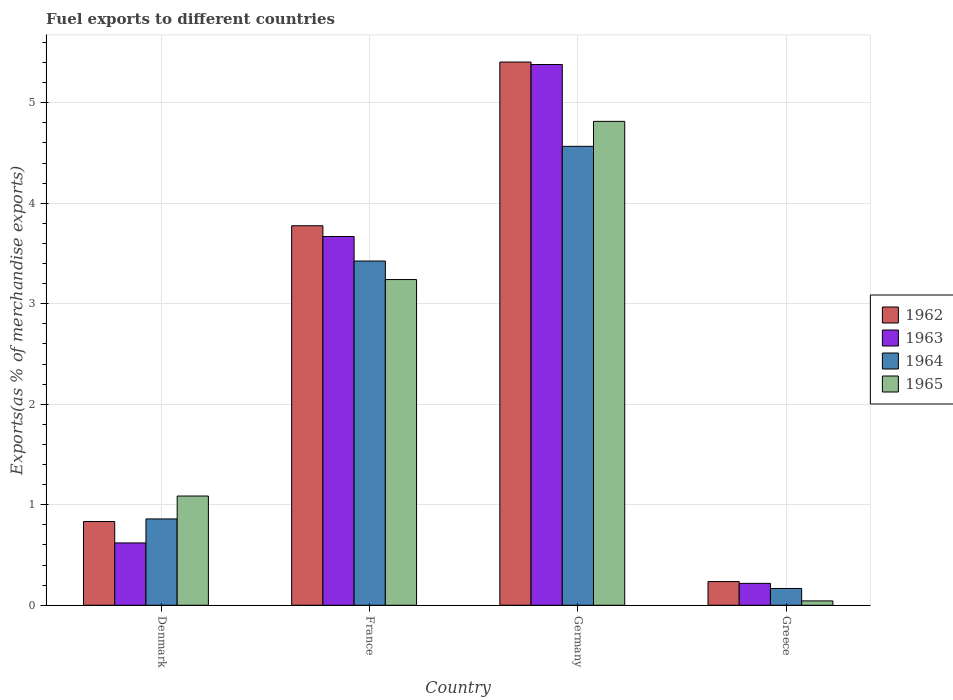How many different coloured bars are there?
Give a very brief answer. 4. How many groups of bars are there?
Ensure brevity in your answer.  4. Are the number of bars on each tick of the X-axis equal?
Make the answer very short. Yes. In how many cases, is the number of bars for a given country not equal to the number of legend labels?
Ensure brevity in your answer.  0. What is the percentage of exports to different countries in 1965 in Denmark?
Your answer should be very brief. 1.09. Across all countries, what is the maximum percentage of exports to different countries in 1963?
Offer a terse response. 5.38. Across all countries, what is the minimum percentage of exports to different countries in 1962?
Your answer should be very brief. 0.24. In which country was the percentage of exports to different countries in 1965 minimum?
Keep it short and to the point. Greece. What is the total percentage of exports to different countries in 1963 in the graph?
Provide a succinct answer. 9.89. What is the difference between the percentage of exports to different countries in 1963 in Denmark and that in Greece?
Give a very brief answer. 0.4. What is the difference between the percentage of exports to different countries in 1965 in Greece and the percentage of exports to different countries in 1962 in Denmark?
Your answer should be very brief. -0.79. What is the average percentage of exports to different countries in 1962 per country?
Provide a succinct answer. 2.56. What is the difference between the percentage of exports to different countries of/in 1962 and percentage of exports to different countries of/in 1964 in Denmark?
Keep it short and to the point. -0.03. In how many countries, is the percentage of exports to different countries in 1964 greater than 2 %?
Your response must be concise. 2. What is the ratio of the percentage of exports to different countries in 1964 in Germany to that in Greece?
Provide a short and direct response. 27.34. Is the difference between the percentage of exports to different countries in 1962 in Germany and Greece greater than the difference between the percentage of exports to different countries in 1964 in Germany and Greece?
Your answer should be very brief. Yes. What is the difference between the highest and the second highest percentage of exports to different countries in 1964?
Keep it short and to the point. -2.57. What is the difference between the highest and the lowest percentage of exports to different countries in 1964?
Offer a very short reply. 4.4. In how many countries, is the percentage of exports to different countries in 1962 greater than the average percentage of exports to different countries in 1962 taken over all countries?
Ensure brevity in your answer.  2. Is the sum of the percentage of exports to different countries in 1964 in Denmark and Germany greater than the maximum percentage of exports to different countries in 1965 across all countries?
Your response must be concise. Yes. Is it the case that in every country, the sum of the percentage of exports to different countries in 1965 and percentage of exports to different countries in 1962 is greater than the percentage of exports to different countries in 1964?
Your answer should be compact. Yes. How many countries are there in the graph?
Offer a terse response. 4. Are the values on the major ticks of Y-axis written in scientific E-notation?
Make the answer very short. No. Does the graph contain any zero values?
Ensure brevity in your answer.  No. How many legend labels are there?
Give a very brief answer. 4. What is the title of the graph?
Keep it short and to the point. Fuel exports to different countries. Does "1987" appear as one of the legend labels in the graph?
Provide a short and direct response. No. What is the label or title of the Y-axis?
Ensure brevity in your answer.  Exports(as % of merchandise exports). What is the Exports(as % of merchandise exports) of 1962 in Denmark?
Ensure brevity in your answer.  0.83. What is the Exports(as % of merchandise exports) of 1963 in Denmark?
Provide a succinct answer. 0.62. What is the Exports(as % of merchandise exports) in 1964 in Denmark?
Offer a terse response. 0.86. What is the Exports(as % of merchandise exports) of 1965 in Denmark?
Ensure brevity in your answer.  1.09. What is the Exports(as % of merchandise exports) of 1962 in France?
Make the answer very short. 3.78. What is the Exports(as % of merchandise exports) of 1963 in France?
Ensure brevity in your answer.  3.67. What is the Exports(as % of merchandise exports) in 1964 in France?
Your response must be concise. 3.43. What is the Exports(as % of merchandise exports) in 1965 in France?
Ensure brevity in your answer.  3.24. What is the Exports(as % of merchandise exports) in 1962 in Germany?
Provide a succinct answer. 5.4. What is the Exports(as % of merchandise exports) of 1963 in Germany?
Offer a terse response. 5.38. What is the Exports(as % of merchandise exports) in 1964 in Germany?
Offer a terse response. 4.57. What is the Exports(as % of merchandise exports) in 1965 in Germany?
Your answer should be compact. 4.81. What is the Exports(as % of merchandise exports) of 1962 in Greece?
Make the answer very short. 0.24. What is the Exports(as % of merchandise exports) in 1963 in Greece?
Offer a very short reply. 0.22. What is the Exports(as % of merchandise exports) of 1964 in Greece?
Your answer should be compact. 0.17. What is the Exports(as % of merchandise exports) in 1965 in Greece?
Your response must be concise. 0.04. Across all countries, what is the maximum Exports(as % of merchandise exports) of 1962?
Offer a terse response. 5.4. Across all countries, what is the maximum Exports(as % of merchandise exports) of 1963?
Your answer should be compact. 5.38. Across all countries, what is the maximum Exports(as % of merchandise exports) in 1964?
Offer a very short reply. 4.57. Across all countries, what is the maximum Exports(as % of merchandise exports) in 1965?
Your response must be concise. 4.81. Across all countries, what is the minimum Exports(as % of merchandise exports) in 1962?
Make the answer very short. 0.24. Across all countries, what is the minimum Exports(as % of merchandise exports) in 1963?
Make the answer very short. 0.22. Across all countries, what is the minimum Exports(as % of merchandise exports) of 1964?
Offer a terse response. 0.17. Across all countries, what is the minimum Exports(as % of merchandise exports) of 1965?
Offer a very short reply. 0.04. What is the total Exports(as % of merchandise exports) in 1962 in the graph?
Ensure brevity in your answer.  10.25. What is the total Exports(as % of merchandise exports) in 1963 in the graph?
Your answer should be very brief. 9.89. What is the total Exports(as % of merchandise exports) of 1964 in the graph?
Offer a very short reply. 9.02. What is the total Exports(as % of merchandise exports) of 1965 in the graph?
Provide a succinct answer. 9.19. What is the difference between the Exports(as % of merchandise exports) in 1962 in Denmark and that in France?
Offer a very short reply. -2.94. What is the difference between the Exports(as % of merchandise exports) of 1963 in Denmark and that in France?
Your response must be concise. -3.05. What is the difference between the Exports(as % of merchandise exports) in 1964 in Denmark and that in France?
Provide a succinct answer. -2.57. What is the difference between the Exports(as % of merchandise exports) in 1965 in Denmark and that in France?
Make the answer very short. -2.15. What is the difference between the Exports(as % of merchandise exports) of 1962 in Denmark and that in Germany?
Ensure brevity in your answer.  -4.57. What is the difference between the Exports(as % of merchandise exports) of 1963 in Denmark and that in Germany?
Provide a succinct answer. -4.76. What is the difference between the Exports(as % of merchandise exports) of 1964 in Denmark and that in Germany?
Your answer should be very brief. -3.71. What is the difference between the Exports(as % of merchandise exports) of 1965 in Denmark and that in Germany?
Make the answer very short. -3.73. What is the difference between the Exports(as % of merchandise exports) of 1962 in Denmark and that in Greece?
Give a very brief answer. 0.6. What is the difference between the Exports(as % of merchandise exports) of 1963 in Denmark and that in Greece?
Offer a very short reply. 0.4. What is the difference between the Exports(as % of merchandise exports) of 1964 in Denmark and that in Greece?
Offer a terse response. 0.69. What is the difference between the Exports(as % of merchandise exports) of 1965 in Denmark and that in Greece?
Ensure brevity in your answer.  1.04. What is the difference between the Exports(as % of merchandise exports) of 1962 in France and that in Germany?
Your answer should be very brief. -1.63. What is the difference between the Exports(as % of merchandise exports) of 1963 in France and that in Germany?
Provide a short and direct response. -1.71. What is the difference between the Exports(as % of merchandise exports) in 1964 in France and that in Germany?
Keep it short and to the point. -1.14. What is the difference between the Exports(as % of merchandise exports) in 1965 in France and that in Germany?
Keep it short and to the point. -1.57. What is the difference between the Exports(as % of merchandise exports) in 1962 in France and that in Greece?
Your response must be concise. 3.54. What is the difference between the Exports(as % of merchandise exports) in 1963 in France and that in Greece?
Provide a short and direct response. 3.45. What is the difference between the Exports(as % of merchandise exports) of 1964 in France and that in Greece?
Offer a very short reply. 3.26. What is the difference between the Exports(as % of merchandise exports) in 1965 in France and that in Greece?
Offer a very short reply. 3.2. What is the difference between the Exports(as % of merchandise exports) in 1962 in Germany and that in Greece?
Your response must be concise. 5.17. What is the difference between the Exports(as % of merchandise exports) of 1963 in Germany and that in Greece?
Provide a succinct answer. 5.16. What is the difference between the Exports(as % of merchandise exports) in 1964 in Germany and that in Greece?
Keep it short and to the point. 4.4. What is the difference between the Exports(as % of merchandise exports) of 1965 in Germany and that in Greece?
Offer a terse response. 4.77. What is the difference between the Exports(as % of merchandise exports) in 1962 in Denmark and the Exports(as % of merchandise exports) in 1963 in France?
Offer a terse response. -2.84. What is the difference between the Exports(as % of merchandise exports) of 1962 in Denmark and the Exports(as % of merchandise exports) of 1964 in France?
Your answer should be compact. -2.59. What is the difference between the Exports(as % of merchandise exports) in 1962 in Denmark and the Exports(as % of merchandise exports) in 1965 in France?
Ensure brevity in your answer.  -2.41. What is the difference between the Exports(as % of merchandise exports) of 1963 in Denmark and the Exports(as % of merchandise exports) of 1964 in France?
Give a very brief answer. -2.8. What is the difference between the Exports(as % of merchandise exports) in 1963 in Denmark and the Exports(as % of merchandise exports) in 1965 in France?
Make the answer very short. -2.62. What is the difference between the Exports(as % of merchandise exports) of 1964 in Denmark and the Exports(as % of merchandise exports) of 1965 in France?
Offer a very short reply. -2.38. What is the difference between the Exports(as % of merchandise exports) of 1962 in Denmark and the Exports(as % of merchandise exports) of 1963 in Germany?
Offer a very short reply. -4.55. What is the difference between the Exports(as % of merchandise exports) of 1962 in Denmark and the Exports(as % of merchandise exports) of 1964 in Germany?
Offer a very short reply. -3.73. What is the difference between the Exports(as % of merchandise exports) of 1962 in Denmark and the Exports(as % of merchandise exports) of 1965 in Germany?
Ensure brevity in your answer.  -3.98. What is the difference between the Exports(as % of merchandise exports) in 1963 in Denmark and the Exports(as % of merchandise exports) in 1964 in Germany?
Offer a terse response. -3.95. What is the difference between the Exports(as % of merchandise exports) in 1963 in Denmark and the Exports(as % of merchandise exports) in 1965 in Germany?
Make the answer very short. -4.19. What is the difference between the Exports(as % of merchandise exports) of 1964 in Denmark and the Exports(as % of merchandise exports) of 1965 in Germany?
Keep it short and to the point. -3.96. What is the difference between the Exports(as % of merchandise exports) in 1962 in Denmark and the Exports(as % of merchandise exports) in 1963 in Greece?
Your answer should be very brief. 0.62. What is the difference between the Exports(as % of merchandise exports) in 1962 in Denmark and the Exports(as % of merchandise exports) in 1964 in Greece?
Your answer should be very brief. 0.67. What is the difference between the Exports(as % of merchandise exports) of 1962 in Denmark and the Exports(as % of merchandise exports) of 1965 in Greece?
Offer a terse response. 0.79. What is the difference between the Exports(as % of merchandise exports) of 1963 in Denmark and the Exports(as % of merchandise exports) of 1964 in Greece?
Your answer should be compact. 0.45. What is the difference between the Exports(as % of merchandise exports) in 1963 in Denmark and the Exports(as % of merchandise exports) in 1965 in Greece?
Your response must be concise. 0.58. What is the difference between the Exports(as % of merchandise exports) in 1964 in Denmark and the Exports(as % of merchandise exports) in 1965 in Greece?
Ensure brevity in your answer.  0.82. What is the difference between the Exports(as % of merchandise exports) of 1962 in France and the Exports(as % of merchandise exports) of 1963 in Germany?
Your answer should be very brief. -1.6. What is the difference between the Exports(as % of merchandise exports) of 1962 in France and the Exports(as % of merchandise exports) of 1964 in Germany?
Your answer should be compact. -0.79. What is the difference between the Exports(as % of merchandise exports) in 1962 in France and the Exports(as % of merchandise exports) in 1965 in Germany?
Ensure brevity in your answer.  -1.04. What is the difference between the Exports(as % of merchandise exports) of 1963 in France and the Exports(as % of merchandise exports) of 1964 in Germany?
Provide a succinct answer. -0.9. What is the difference between the Exports(as % of merchandise exports) in 1963 in France and the Exports(as % of merchandise exports) in 1965 in Germany?
Give a very brief answer. -1.15. What is the difference between the Exports(as % of merchandise exports) in 1964 in France and the Exports(as % of merchandise exports) in 1965 in Germany?
Ensure brevity in your answer.  -1.39. What is the difference between the Exports(as % of merchandise exports) of 1962 in France and the Exports(as % of merchandise exports) of 1963 in Greece?
Your answer should be very brief. 3.56. What is the difference between the Exports(as % of merchandise exports) in 1962 in France and the Exports(as % of merchandise exports) in 1964 in Greece?
Provide a short and direct response. 3.61. What is the difference between the Exports(as % of merchandise exports) of 1962 in France and the Exports(as % of merchandise exports) of 1965 in Greece?
Give a very brief answer. 3.73. What is the difference between the Exports(as % of merchandise exports) of 1963 in France and the Exports(as % of merchandise exports) of 1964 in Greece?
Keep it short and to the point. 3.5. What is the difference between the Exports(as % of merchandise exports) of 1963 in France and the Exports(as % of merchandise exports) of 1965 in Greece?
Your answer should be very brief. 3.63. What is the difference between the Exports(as % of merchandise exports) in 1964 in France and the Exports(as % of merchandise exports) in 1965 in Greece?
Offer a very short reply. 3.38. What is the difference between the Exports(as % of merchandise exports) of 1962 in Germany and the Exports(as % of merchandise exports) of 1963 in Greece?
Give a very brief answer. 5.19. What is the difference between the Exports(as % of merchandise exports) of 1962 in Germany and the Exports(as % of merchandise exports) of 1964 in Greece?
Your answer should be very brief. 5.24. What is the difference between the Exports(as % of merchandise exports) of 1962 in Germany and the Exports(as % of merchandise exports) of 1965 in Greece?
Offer a very short reply. 5.36. What is the difference between the Exports(as % of merchandise exports) of 1963 in Germany and the Exports(as % of merchandise exports) of 1964 in Greece?
Make the answer very short. 5.21. What is the difference between the Exports(as % of merchandise exports) of 1963 in Germany and the Exports(as % of merchandise exports) of 1965 in Greece?
Ensure brevity in your answer.  5.34. What is the difference between the Exports(as % of merchandise exports) of 1964 in Germany and the Exports(as % of merchandise exports) of 1965 in Greece?
Your answer should be compact. 4.52. What is the average Exports(as % of merchandise exports) of 1962 per country?
Your answer should be very brief. 2.56. What is the average Exports(as % of merchandise exports) in 1963 per country?
Offer a very short reply. 2.47. What is the average Exports(as % of merchandise exports) of 1964 per country?
Keep it short and to the point. 2.25. What is the average Exports(as % of merchandise exports) of 1965 per country?
Ensure brevity in your answer.  2.3. What is the difference between the Exports(as % of merchandise exports) in 1962 and Exports(as % of merchandise exports) in 1963 in Denmark?
Give a very brief answer. 0.21. What is the difference between the Exports(as % of merchandise exports) of 1962 and Exports(as % of merchandise exports) of 1964 in Denmark?
Your response must be concise. -0.03. What is the difference between the Exports(as % of merchandise exports) in 1962 and Exports(as % of merchandise exports) in 1965 in Denmark?
Make the answer very short. -0.25. What is the difference between the Exports(as % of merchandise exports) in 1963 and Exports(as % of merchandise exports) in 1964 in Denmark?
Ensure brevity in your answer.  -0.24. What is the difference between the Exports(as % of merchandise exports) in 1963 and Exports(as % of merchandise exports) in 1965 in Denmark?
Give a very brief answer. -0.47. What is the difference between the Exports(as % of merchandise exports) of 1964 and Exports(as % of merchandise exports) of 1965 in Denmark?
Give a very brief answer. -0.23. What is the difference between the Exports(as % of merchandise exports) in 1962 and Exports(as % of merchandise exports) in 1963 in France?
Your answer should be compact. 0.11. What is the difference between the Exports(as % of merchandise exports) of 1962 and Exports(as % of merchandise exports) of 1964 in France?
Offer a very short reply. 0.35. What is the difference between the Exports(as % of merchandise exports) in 1962 and Exports(as % of merchandise exports) in 1965 in France?
Provide a succinct answer. 0.54. What is the difference between the Exports(as % of merchandise exports) of 1963 and Exports(as % of merchandise exports) of 1964 in France?
Ensure brevity in your answer.  0.24. What is the difference between the Exports(as % of merchandise exports) of 1963 and Exports(as % of merchandise exports) of 1965 in France?
Provide a short and direct response. 0.43. What is the difference between the Exports(as % of merchandise exports) of 1964 and Exports(as % of merchandise exports) of 1965 in France?
Offer a terse response. 0.18. What is the difference between the Exports(as % of merchandise exports) in 1962 and Exports(as % of merchandise exports) in 1963 in Germany?
Keep it short and to the point. 0.02. What is the difference between the Exports(as % of merchandise exports) of 1962 and Exports(as % of merchandise exports) of 1964 in Germany?
Ensure brevity in your answer.  0.84. What is the difference between the Exports(as % of merchandise exports) in 1962 and Exports(as % of merchandise exports) in 1965 in Germany?
Offer a very short reply. 0.59. What is the difference between the Exports(as % of merchandise exports) in 1963 and Exports(as % of merchandise exports) in 1964 in Germany?
Your response must be concise. 0.81. What is the difference between the Exports(as % of merchandise exports) of 1963 and Exports(as % of merchandise exports) of 1965 in Germany?
Your answer should be compact. 0.57. What is the difference between the Exports(as % of merchandise exports) of 1964 and Exports(as % of merchandise exports) of 1965 in Germany?
Make the answer very short. -0.25. What is the difference between the Exports(as % of merchandise exports) of 1962 and Exports(as % of merchandise exports) of 1963 in Greece?
Make the answer very short. 0.02. What is the difference between the Exports(as % of merchandise exports) of 1962 and Exports(as % of merchandise exports) of 1964 in Greece?
Offer a very short reply. 0.07. What is the difference between the Exports(as % of merchandise exports) in 1962 and Exports(as % of merchandise exports) in 1965 in Greece?
Provide a short and direct response. 0.19. What is the difference between the Exports(as % of merchandise exports) of 1963 and Exports(as % of merchandise exports) of 1964 in Greece?
Ensure brevity in your answer.  0.05. What is the difference between the Exports(as % of merchandise exports) of 1963 and Exports(as % of merchandise exports) of 1965 in Greece?
Give a very brief answer. 0.17. What is the difference between the Exports(as % of merchandise exports) of 1964 and Exports(as % of merchandise exports) of 1965 in Greece?
Ensure brevity in your answer.  0.12. What is the ratio of the Exports(as % of merchandise exports) of 1962 in Denmark to that in France?
Your answer should be very brief. 0.22. What is the ratio of the Exports(as % of merchandise exports) of 1963 in Denmark to that in France?
Give a very brief answer. 0.17. What is the ratio of the Exports(as % of merchandise exports) in 1964 in Denmark to that in France?
Give a very brief answer. 0.25. What is the ratio of the Exports(as % of merchandise exports) of 1965 in Denmark to that in France?
Make the answer very short. 0.34. What is the ratio of the Exports(as % of merchandise exports) of 1962 in Denmark to that in Germany?
Your answer should be very brief. 0.15. What is the ratio of the Exports(as % of merchandise exports) of 1963 in Denmark to that in Germany?
Ensure brevity in your answer.  0.12. What is the ratio of the Exports(as % of merchandise exports) of 1964 in Denmark to that in Germany?
Offer a very short reply. 0.19. What is the ratio of the Exports(as % of merchandise exports) of 1965 in Denmark to that in Germany?
Make the answer very short. 0.23. What is the ratio of the Exports(as % of merchandise exports) in 1962 in Denmark to that in Greece?
Offer a very short reply. 3.53. What is the ratio of the Exports(as % of merchandise exports) in 1963 in Denmark to that in Greece?
Keep it short and to the point. 2.85. What is the ratio of the Exports(as % of merchandise exports) of 1964 in Denmark to that in Greece?
Ensure brevity in your answer.  5.14. What is the ratio of the Exports(as % of merchandise exports) in 1965 in Denmark to that in Greece?
Offer a terse response. 25.05. What is the ratio of the Exports(as % of merchandise exports) of 1962 in France to that in Germany?
Your answer should be compact. 0.7. What is the ratio of the Exports(as % of merchandise exports) in 1963 in France to that in Germany?
Ensure brevity in your answer.  0.68. What is the ratio of the Exports(as % of merchandise exports) of 1964 in France to that in Germany?
Offer a terse response. 0.75. What is the ratio of the Exports(as % of merchandise exports) in 1965 in France to that in Germany?
Your response must be concise. 0.67. What is the ratio of the Exports(as % of merchandise exports) of 1962 in France to that in Greece?
Keep it short and to the point. 16.01. What is the ratio of the Exports(as % of merchandise exports) in 1963 in France to that in Greece?
Ensure brevity in your answer.  16.85. What is the ratio of the Exports(as % of merchandise exports) of 1964 in France to that in Greece?
Make the answer very short. 20.5. What is the ratio of the Exports(as % of merchandise exports) of 1965 in France to that in Greece?
Offer a terse response. 74.69. What is the ratio of the Exports(as % of merchandise exports) of 1962 in Germany to that in Greece?
Offer a very short reply. 22.91. What is the ratio of the Exports(as % of merchandise exports) of 1963 in Germany to that in Greece?
Your answer should be very brief. 24.71. What is the ratio of the Exports(as % of merchandise exports) of 1964 in Germany to that in Greece?
Your response must be concise. 27.34. What is the ratio of the Exports(as % of merchandise exports) of 1965 in Germany to that in Greece?
Keep it short and to the point. 110.96. What is the difference between the highest and the second highest Exports(as % of merchandise exports) in 1962?
Give a very brief answer. 1.63. What is the difference between the highest and the second highest Exports(as % of merchandise exports) in 1963?
Your answer should be compact. 1.71. What is the difference between the highest and the second highest Exports(as % of merchandise exports) in 1964?
Keep it short and to the point. 1.14. What is the difference between the highest and the second highest Exports(as % of merchandise exports) of 1965?
Give a very brief answer. 1.57. What is the difference between the highest and the lowest Exports(as % of merchandise exports) in 1962?
Offer a terse response. 5.17. What is the difference between the highest and the lowest Exports(as % of merchandise exports) of 1963?
Offer a terse response. 5.16. What is the difference between the highest and the lowest Exports(as % of merchandise exports) of 1964?
Provide a short and direct response. 4.4. What is the difference between the highest and the lowest Exports(as % of merchandise exports) in 1965?
Offer a terse response. 4.77. 